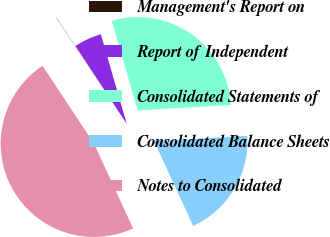<chart> <loc_0><loc_0><loc_500><loc_500><pie_chart><fcel>Management's Report on<fcel>Report of Independent<fcel>Consolidated Statements of<fcel>Consolidated Balance Sheets<fcel>Notes to Consolidated<nl><fcel>0.04%<fcel>4.79%<fcel>28.55%<fcel>19.05%<fcel>47.56%<nl></chart> 